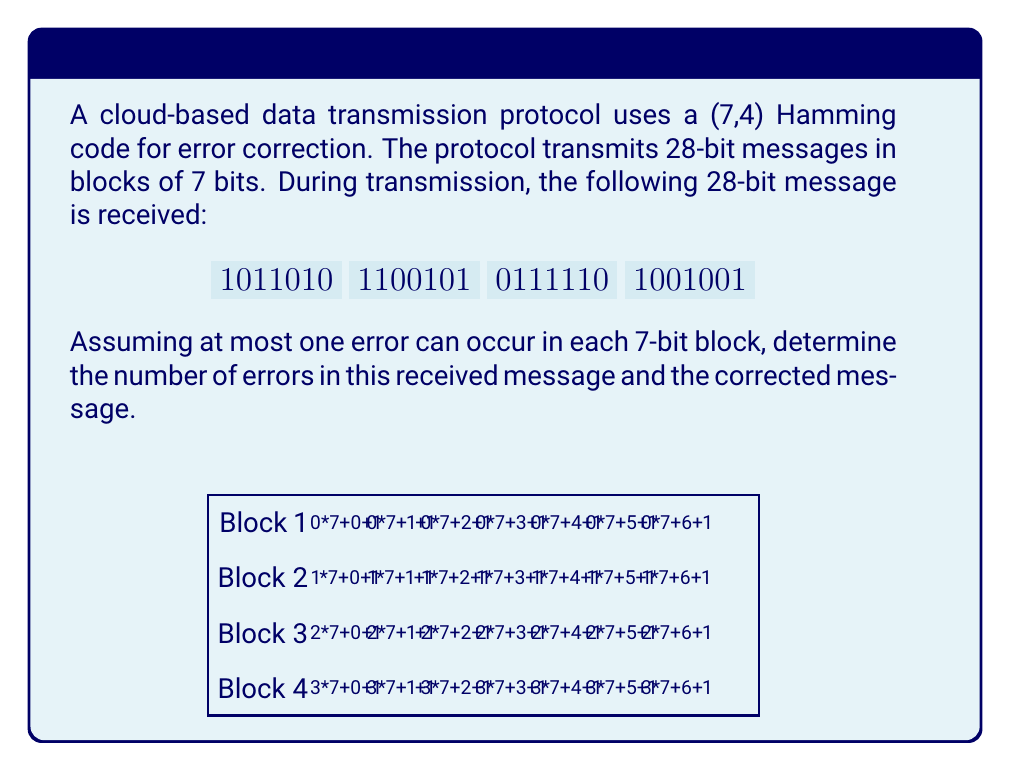Teach me how to tackle this problem. Let's analyze each 7-bit block using the (7,4) Hamming code:

1) For a (7,4) Hamming code, the parity check matrix H is:

   $$H = \begin{bmatrix}
   1 & 1 & 1 & 0 & 1 & 0 & 0 \\
   1 & 1 & 0 & 1 & 0 & 1 & 0 \\
   1 & 0 & 1 & 1 & 0 & 0 & 1
   \end{bmatrix}$$

2) For each block, we calculate the syndrome $s = Hr$ (mod 2), where $r$ is the received codeword.

3) Block 1: $1011010$
   $s_1 = \begin{bmatrix} 1 \\ 1 \\ 0 \end{bmatrix}$
   This corresponds to an error in bit 2. Corrected: $1111010$

4) Block 2: $1100101$
   $s_2 = \begin{bmatrix} 0 \\ 0 \\ 0 \end{bmatrix}$
   No error detected.

5) Block 3: $0111110$
   $s_3 = \begin{bmatrix} 1 \\ 0 \\ 1 \end{bmatrix}$
   This corresponds to an error in bit 5. Corrected: $0111010$

6) Block 4: $1001001$
   $s_4 = \begin{bmatrix} 0 \\ 0 \\ 0 \end{bmatrix}$
   No error detected.

7) The total number of errors is 2 (in blocks 1 and 3).

8) The corrected 28-bit message is:
   $$1111010 \: 1100101 \: 0111010 \: 1001001$$
Answer: 2 errors; corrected message: 1111010110010101110101001001 